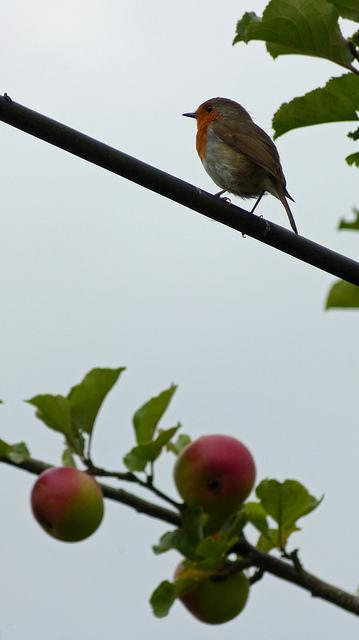How many birds are hanging upside down? zero 